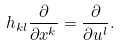<formula> <loc_0><loc_0><loc_500><loc_500>h _ { k l } \frac { \partial } { \partial x ^ { k } } = \frac { \partial } { \partial u ^ { l } } .</formula> 